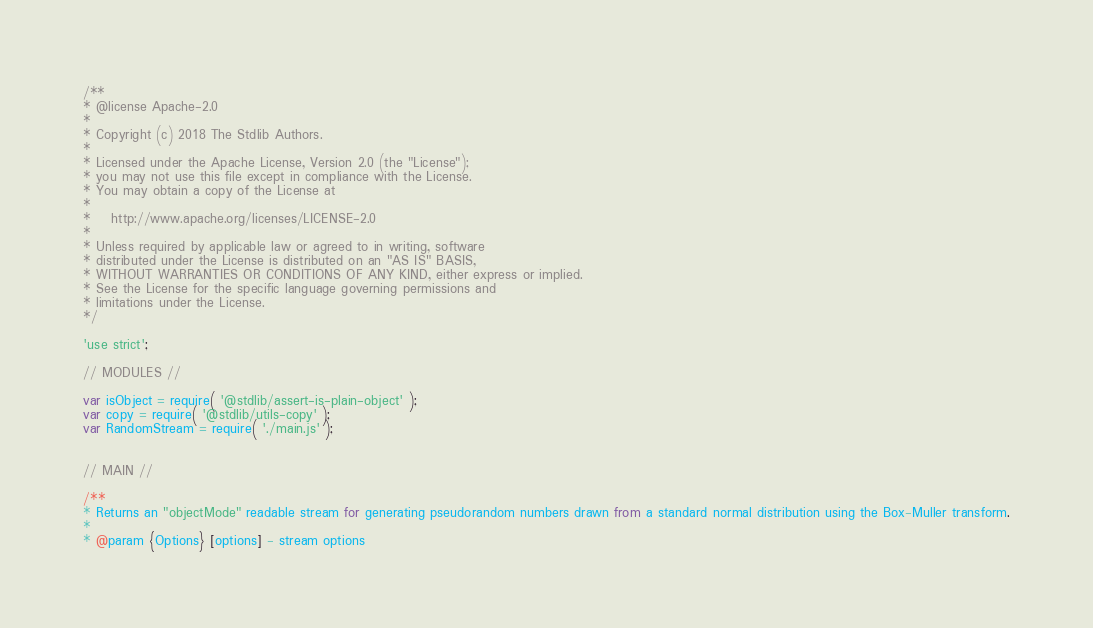<code> <loc_0><loc_0><loc_500><loc_500><_JavaScript_>/**
* @license Apache-2.0
*
* Copyright (c) 2018 The Stdlib Authors.
*
* Licensed under the Apache License, Version 2.0 (the "License");
* you may not use this file except in compliance with the License.
* You may obtain a copy of the License at
*
*    http://www.apache.org/licenses/LICENSE-2.0
*
* Unless required by applicable law or agreed to in writing, software
* distributed under the License is distributed on an "AS IS" BASIS,
* WITHOUT WARRANTIES OR CONDITIONS OF ANY KIND, either express or implied.
* See the License for the specific language governing permissions and
* limitations under the License.
*/

'use strict';

// MODULES //

var isObject = require( '@stdlib/assert-is-plain-object' );
var copy = require( '@stdlib/utils-copy' );
var RandomStream = require( './main.js' );


// MAIN //

/**
* Returns an "objectMode" readable stream for generating pseudorandom numbers drawn from a standard normal distribution using the Box-Muller transform.
*
* @param {Options} [options] - stream options</code> 